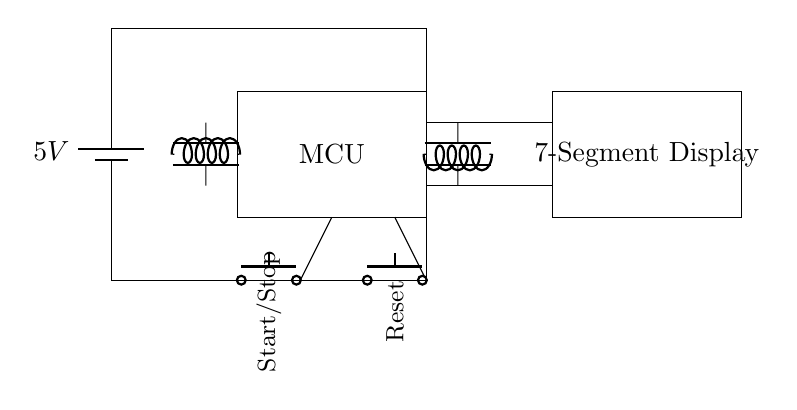What is the power supply voltage? The circuit is powered by a battery labeled as 5V, indicating the voltage supplied to the entire circuit.
Answer: 5V What components are used for timing? The timing mechanism is likely managed by the microcontroller (MCU) as it handles processing and control logic, but the circuit also includes a crystal oscillator which stabilizes the clock frequency for accurate timing.
Answer: MCU and Crystal Oscillator How many buttons are present in the circuit? There are two buttons visible in the diagram: one for Start/Stop and another for Reset. This total is derived from counting the push button components shown in the diagram.
Answer: 2 What type of display is used? The circuit uses a seven-segment display which is indicated in the diagram, designed to show numerical values corresponding to the timer's count.
Answer: 7-Segment Display What is the function of the reset button? The reset button in the circuit is designed to reset the timer to its initial state, allowing the user to start timing from zero again.
Answer: Reset Timer How is the microcontroller connected in the circuit? The microcontroller is centrally located and connected to both the power supply and the display, showing that it manages timing and data output, while receiving power for operation.
Answer: Centrally connected to power and display How does the crystal oscillator contribute to the circuit? The crystal oscillator provides a stable clock signal to the microcontroller, ensuring that the timer operates accurately over time, which is essential for precise timing.
Answer: Provides stable clock signal 